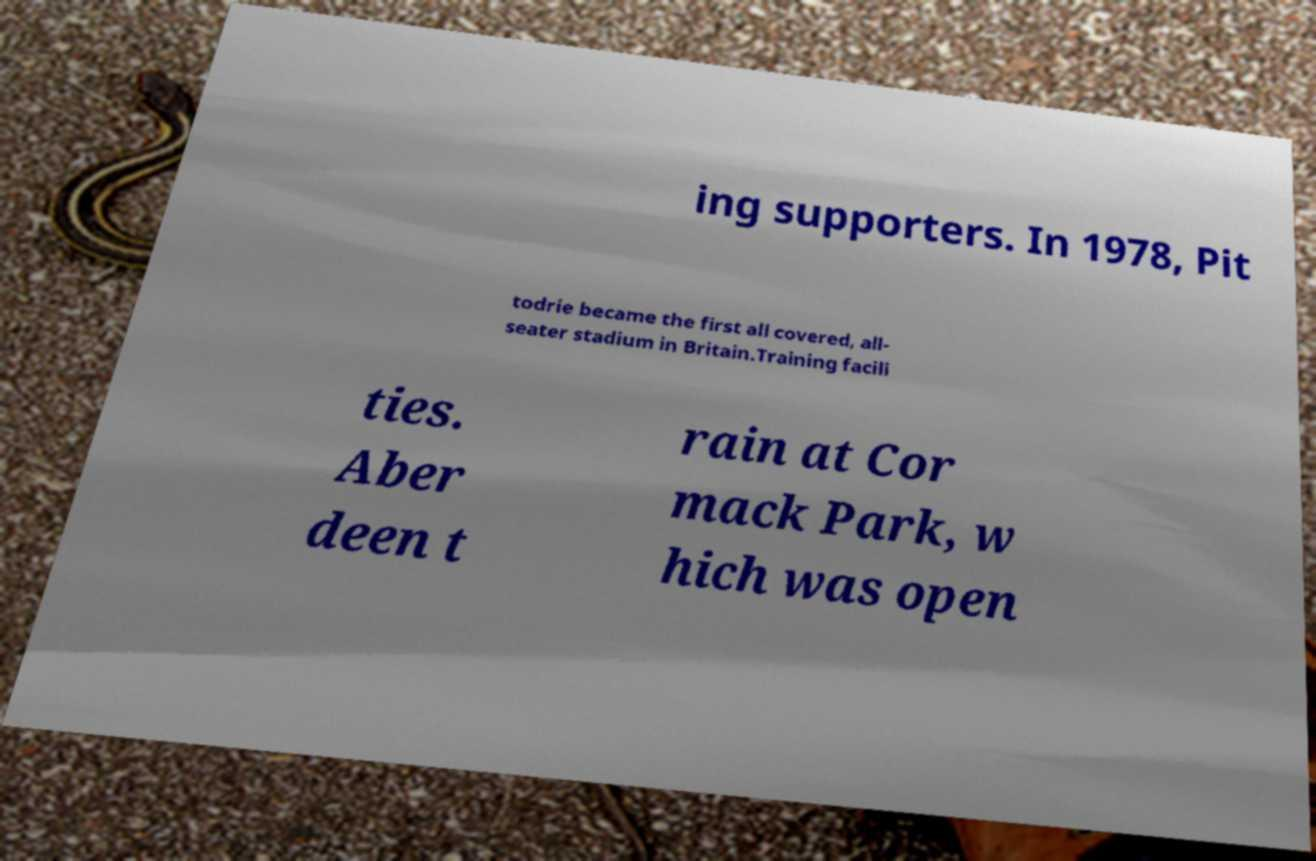Could you extract and type out the text from this image? ing supporters. In 1978, Pit todrie became the first all covered, all- seater stadium in Britain.Training facili ties. Aber deen t rain at Cor mack Park, w hich was open 